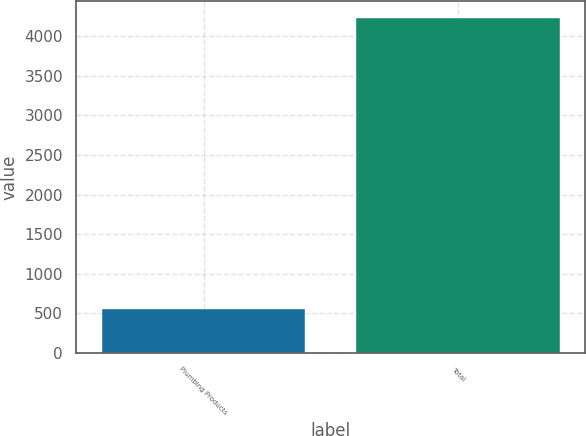<chart> <loc_0><loc_0><loc_500><loc_500><bar_chart><fcel>Plumbing Products<fcel>Total<nl><fcel>549<fcel>4231<nl></chart> 